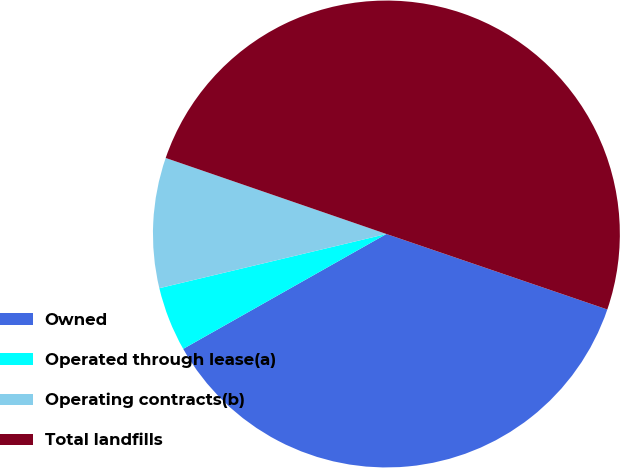Convert chart to OTSL. <chart><loc_0><loc_0><loc_500><loc_500><pie_chart><fcel>Owned<fcel>Operated through lease(a)<fcel>Operating contracts(b)<fcel>Total landfills<nl><fcel>36.57%<fcel>4.46%<fcel>9.01%<fcel>49.96%<nl></chart> 